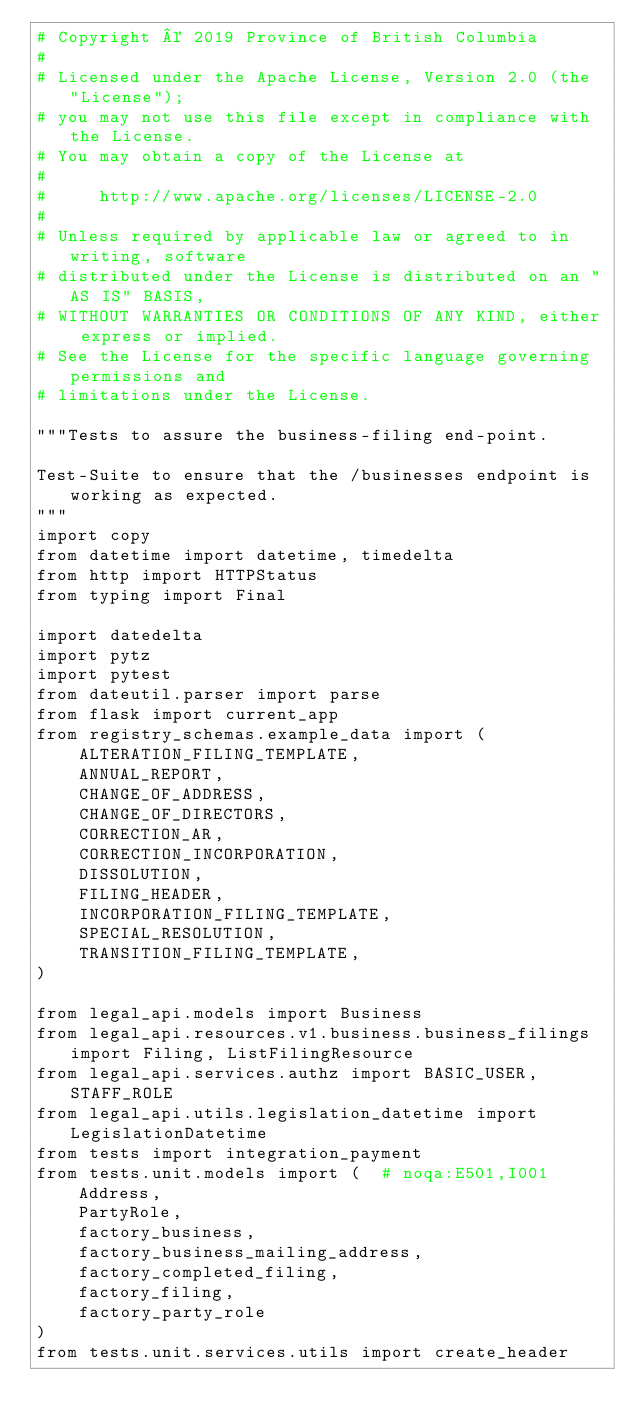<code> <loc_0><loc_0><loc_500><loc_500><_Python_># Copyright © 2019 Province of British Columbia
#
# Licensed under the Apache License, Version 2.0 (the "License");
# you may not use this file except in compliance with the License.
# You may obtain a copy of the License at
#
#     http://www.apache.org/licenses/LICENSE-2.0
#
# Unless required by applicable law or agreed to in writing, software
# distributed under the License is distributed on an "AS IS" BASIS,
# WITHOUT WARRANTIES OR CONDITIONS OF ANY KIND, either express or implied.
# See the License for the specific language governing permissions and
# limitations under the License.

"""Tests to assure the business-filing end-point.

Test-Suite to ensure that the /businesses endpoint is working as expected.
"""
import copy
from datetime import datetime, timedelta
from http import HTTPStatus
from typing import Final

import datedelta
import pytz
import pytest
from dateutil.parser import parse
from flask import current_app
from registry_schemas.example_data import (
    ALTERATION_FILING_TEMPLATE,
    ANNUAL_REPORT,
    CHANGE_OF_ADDRESS,
    CHANGE_OF_DIRECTORS,
    CORRECTION_AR,
    CORRECTION_INCORPORATION,
    DISSOLUTION,
    FILING_HEADER,
    INCORPORATION_FILING_TEMPLATE,
    SPECIAL_RESOLUTION,
    TRANSITION_FILING_TEMPLATE,
)

from legal_api.models import Business
from legal_api.resources.v1.business.business_filings import Filing, ListFilingResource
from legal_api.services.authz import BASIC_USER, STAFF_ROLE
from legal_api.utils.legislation_datetime import LegislationDatetime
from tests import integration_payment
from tests.unit.models import (  # noqa:E501,I001
    Address,
    PartyRole,
    factory_business,
    factory_business_mailing_address,
    factory_completed_filing,
    factory_filing,
    factory_party_role
)
from tests.unit.services.utils import create_header

</code> 